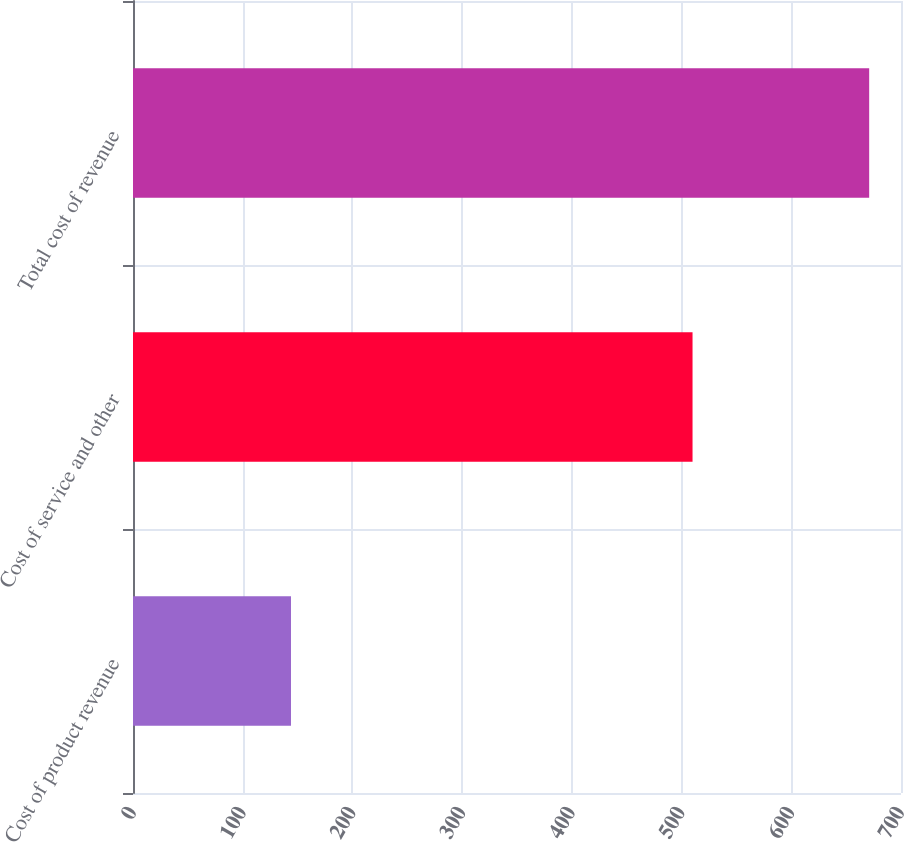Convert chart to OTSL. <chart><loc_0><loc_0><loc_500><loc_500><bar_chart><fcel>Cost of product revenue<fcel>Cost of service and other<fcel>Total cost of revenue<nl><fcel>144<fcel>510<fcel>671<nl></chart> 